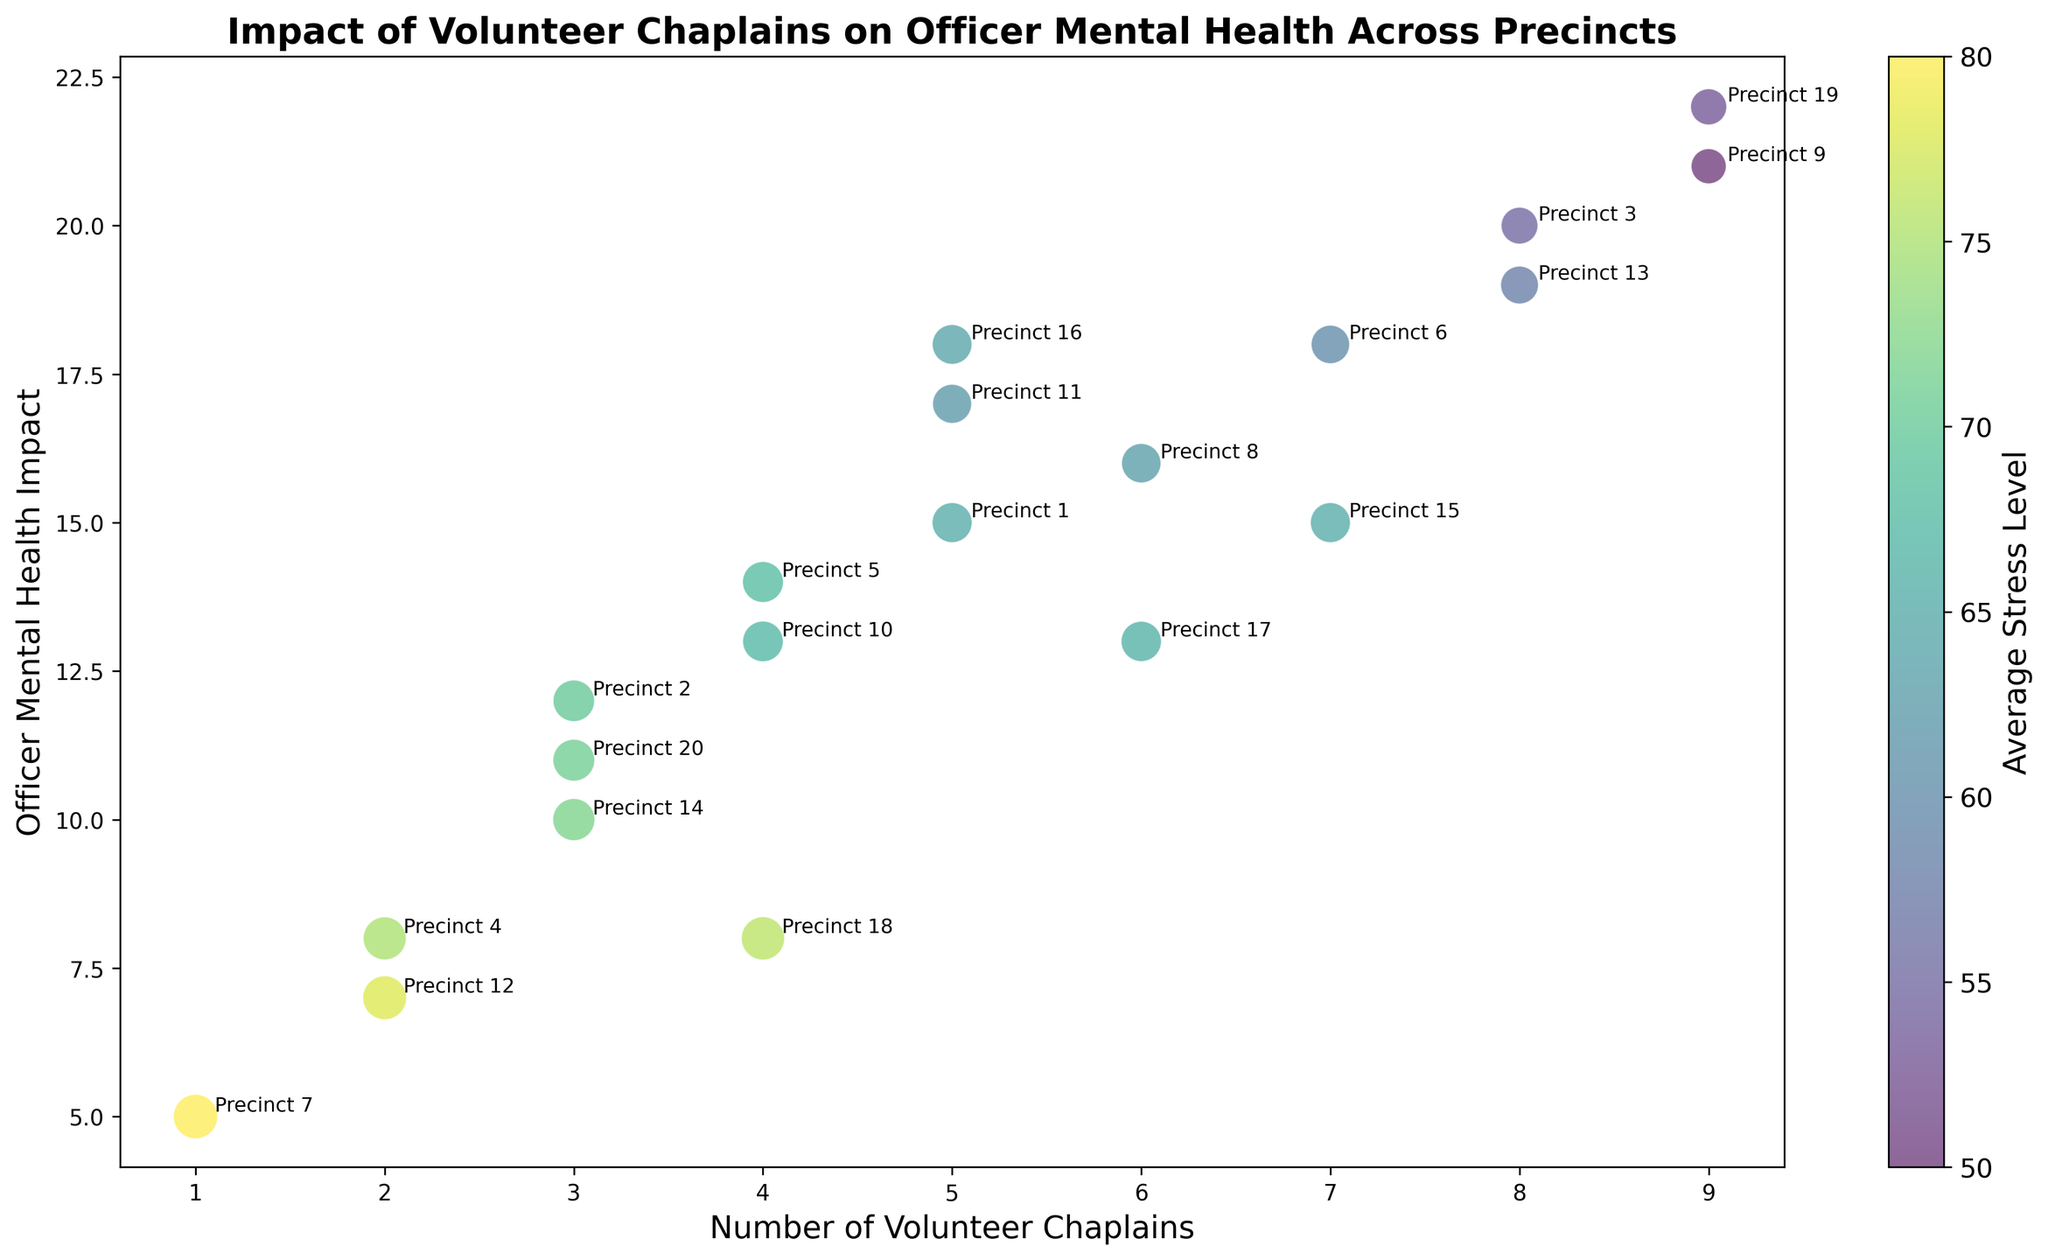What precinct has the highest officer mental health impact? To determine the precinct with the highest officer mental health impact, look at the bubble with the highest position on the y-axis. Precinct 19 has the highest officer mental health impact with a value of 22.
Answer: Precinct 19 What is the relationship between the number of volunteer chaplains and officer mental health impact? Examine the general trend in the bubbles between the x-axis (number of chaplains) and y-axis (mental health impact). Generally, the bubbles trend upwards along the y-axis as the number of chaplains increases. This indicates a positive relationship where more chaplains are associated with a higher officer mental health impact.
Answer: Positive Which precinct has the lowest average stress level? Look at the color of the bubbles (indicated by the color bar) and find the bubble corresponding to the lowest average stress level, which will be the darkest on the color scale. Precinct 9 has the lowest average stress level with a value of 50.
Answer: Precinct 9 What is the total number of volunteer chaplains in precincts with an average stress level above 70? Review the color legend and identify the bubbles with stress levels above 70, which are precincts 2, 4, 7, 12, 14, and 18. Sum their numbers of volunteer chaplains. The numbers are: 3 + 2 + 1 + 2 + 3 + 4 = 15.
Answer: 15 How does average stress level correlate visually with the size of bubbles? Examine the size of the bubbles and their corresponding average stress levels on the color scale. Larger bubbles (representing higher stress levels) tend to have brighter colors (towards the yellow end of the spectrum), indicating a correlation where higher stress levels are represented by larger bubbles.
Answer: Larger bubbles correspond to higher stress levels What effect does precinct 9 have on officer mental health compared to precinct 7? Find precinct 9 and precinct 7 on the plot and compare their positions on the y-axis. Precinct 9 has a mental health impact of 21, while precinct 7 has a mental health impact of 5. Thus, precinct 9 has a much higher impact on officer mental health compared to precinct 7.
Answer: Precinct 9 has a higher impact Between precinct 13 and precinct 5, which has a lower average stress level? Compare the colors of the bubbles representing precinct 13 and precinct 5 based on the color bar. Precinct 13 has a lighter color indicating a lower stress level of 58, while precinct 5 has a stress level of 68.
Answer: Precinct 13 How many precincts have an officer mental health impact above 18? Identify the precincts whose bubbles are positioned above the y-axis value of 18: precincts 3, 6, 9, 13, 16, and 19. Therefore, there are 6 precincts with an officer mental health impact above 18.
Answer: 6 What is the average officer mental health impact for precincts with exactly 5 volunteer chaplains? Identify the precincts with exactly 5 volunteer chaplains and determine their mental health impacts: precincts 1 (15), 11 (17), and 16 (18). The average is calculated as (15 + 17 + 18) / 3 = 16.67.
Answer: 16.67 Which precinct has the smallest bubble, and what is its average stress level? Identify the smallest bubble by its size on the chart, which represents precinct 7. Its average stress level, indicated by the color bar, is 80.
Answer: Precinct 7, 80 